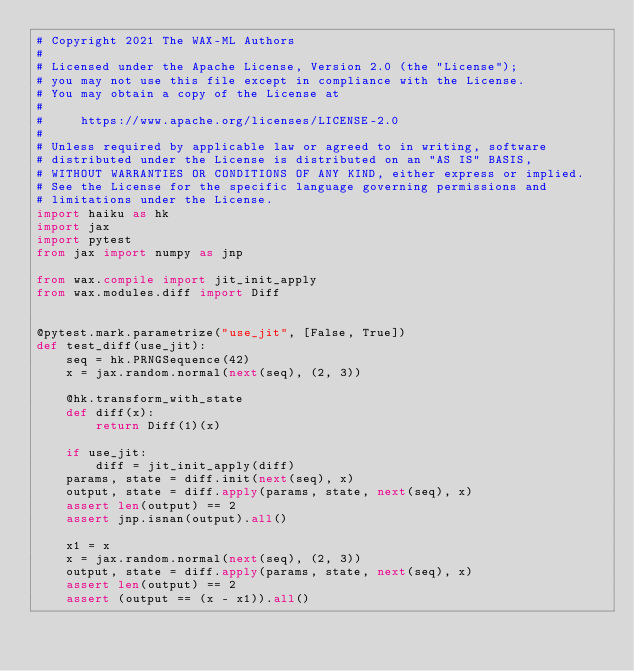Convert code to text. <code><loc_0><loc_0><loc_500><loc_500><_Python_># Copyright 2021 The WAX-ML Authors
#
# Licensed under the Apache License, Version 2.0 (the "License");
# you may not use this file except in compliance with the License.
# You may obtain a copy of the License at
#
#     https://www.apache.org/licenses/LICENSE-2.0
#
# Unless required by applicable law or agreed to in writing, software
# distributed under the License is distributed on an "AS IS" BASIS,
# WITHOUT WARRANTIES OR CONDITIONS OF ANY KIND, either express or implied.
# See the License for the specific language governing permissions and
# limitations under the License.
import haiku as hk
import jax
import pytest
from jax import numpy as jnp

from wax.compile import jit_init_apply
from wax.modules.diff import Diff


@pytest.mark.parametrize("use_jit", [False, True])
def test_diff(use_jit):
    seq = hk.PRNGSequence(42)
    x = jax.random.normal(next(seq), (2, 3))

    @hk.transform_with_state
    def diff(x):
        return Diff(1)(x)

    if use_jit:
        diff = jit_init_apply(diff)
    params, state = diff.init(next(seq), x)
    output, state = diff.apply(params, state, next(seq), x)
    assert len(output) == 2
    assert jnp.isnan(output).all()

    x1 = x
    x = jax.random.normal(next(seq), (2, 3))
    output, state = diff.apply(params, state, next(seq), x)
    assert len(output) == 2
    assert (output == (x - x1)).all()
</code> 